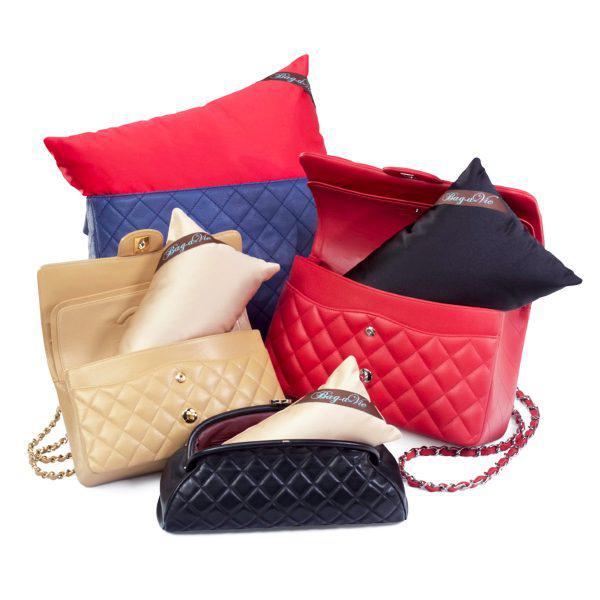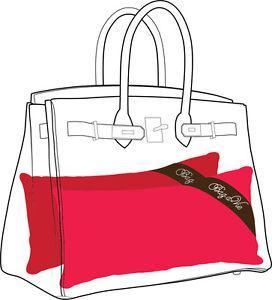The first image is the image on the left, the second image is the image on the right. For the images displayed, is the sentence "Each image shows two different colored handbags with double handles and metal trim sitting behind a white stuffed pillow form." factually correct? Answer yes or no. No. The first image is the image on the left, the second image is the image on the right. Assess this claim about the two images: "At least one image shows a dark brown bag and a golden-yellow bag behind a white pillow.". Correct or not? Answer yes or no. No. 